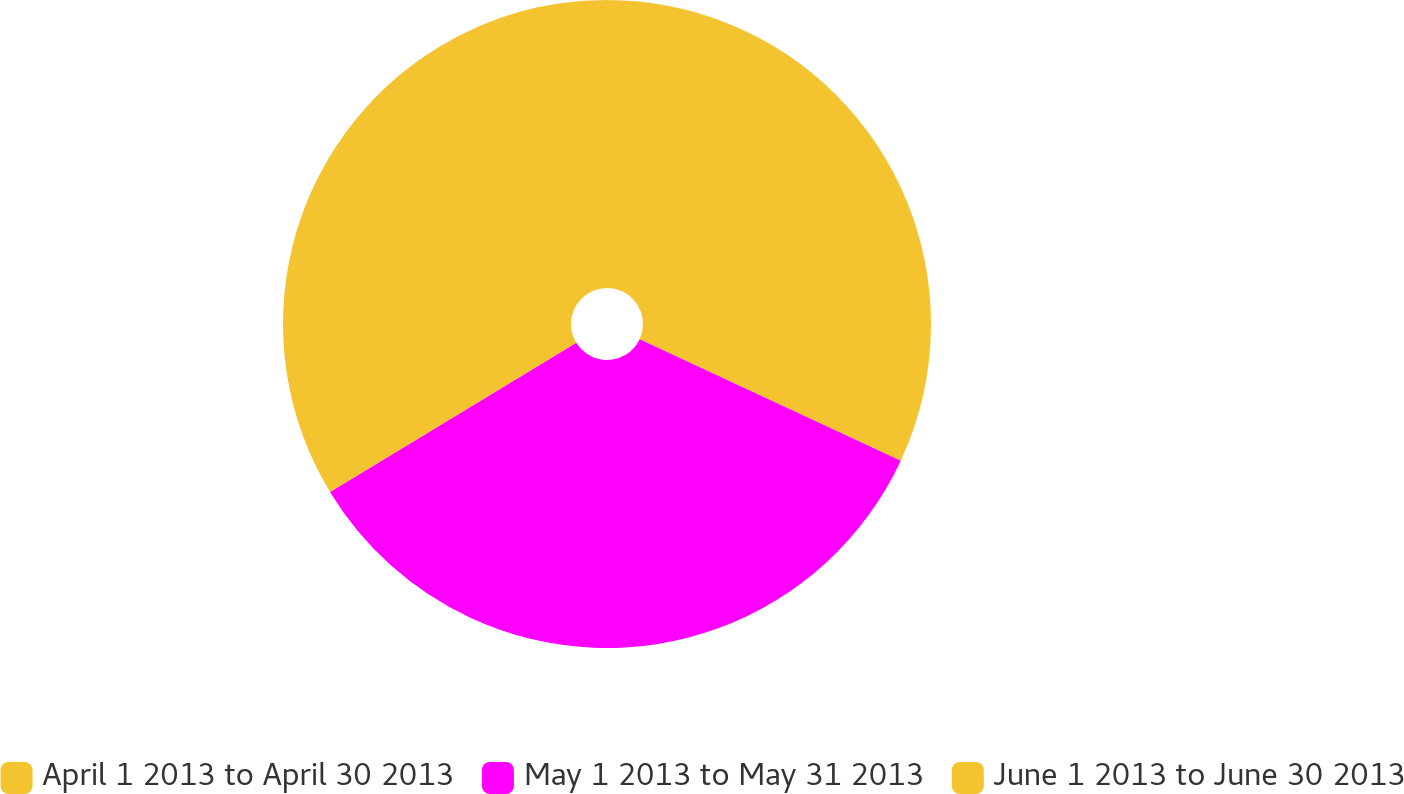<chart> <loc_0><loc_0><loc_500><loc_500><pie_chart><fcel>April 1 2013 to April 30 2013<fcel>May 1 2013 to May 31 2013<fcel>June 1 2013 to June 30 2013<nl><fcel>31.93%<fcel>34.39%<fcel>33.68%<nl></chart> 